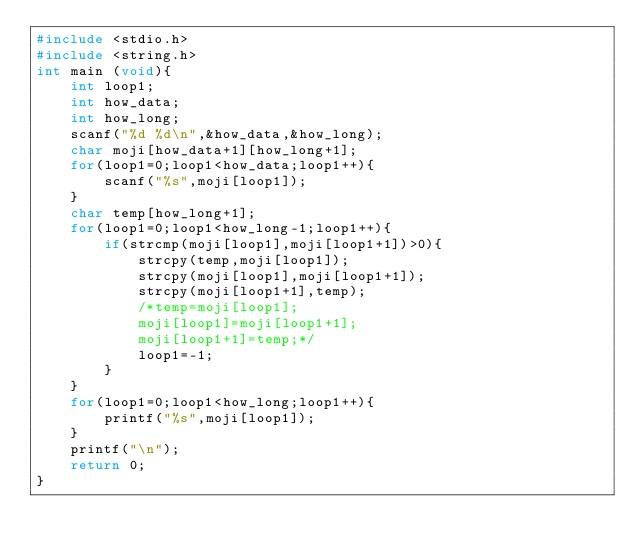<code> <loc_0><loc_0><loc_500><loc_500><_C_>#include <stdio.h>
#include <string.h>
int main (void){
    int loop1;
    int how_data;
    int how_long;
    scanf("%d %d\n",&how_data,&how_long);
    char moji[how_data+1][how_long+1];
    for(loop1=0;loop1<how_data;loop1++){
        scanf("%s",moji[loop1]);
    }
    char temp[how_long+1];
    for(loop1=0;loop1<how_long-1;loop1++){
        if(strcmp(moji[loop1],moji[loop1+1])>0){
            strcpy(temp,moji[loop1]);
            strcpy(moji[loop1],moji[loop1+1]);
            strcpy(moji[loop1+1],temp);
            /*temp=moji[loop1];
            moji[loop1]=moji[loop1+1];
            moji[loop1+1]=temp;*/
            loop1=-1;
        }
    }
    for(loop1=0;loop1<how_long;loop1++){
        printf("%s",moji[loop1]);
    }
    printf("\n");
    return 0;
}</code> 